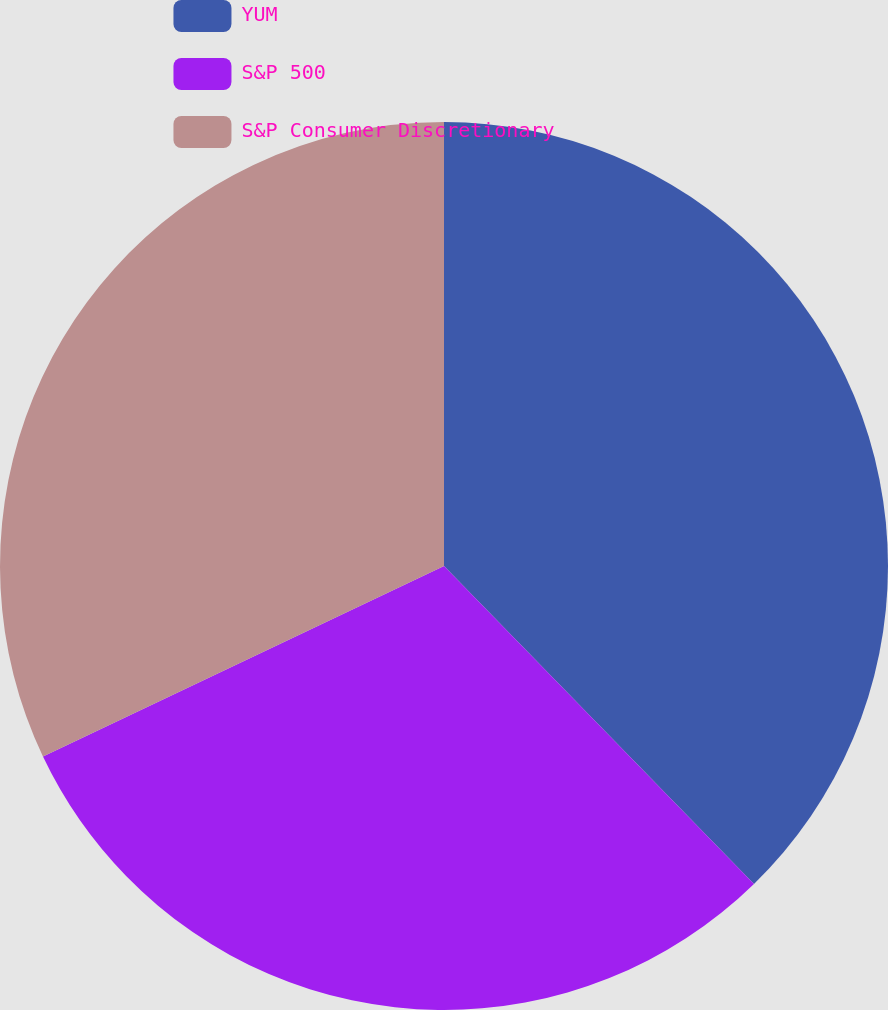Convert chart. <chart><loc_0><loc_0><loc_500><loc_500><pie_chart><fcel>YUM<fcel>S&P 500<fcel>S&P Consumer Discretionary<nl><fcel>37.7%<fcel>30.24%<fcel>32.06%<nl></chart> 